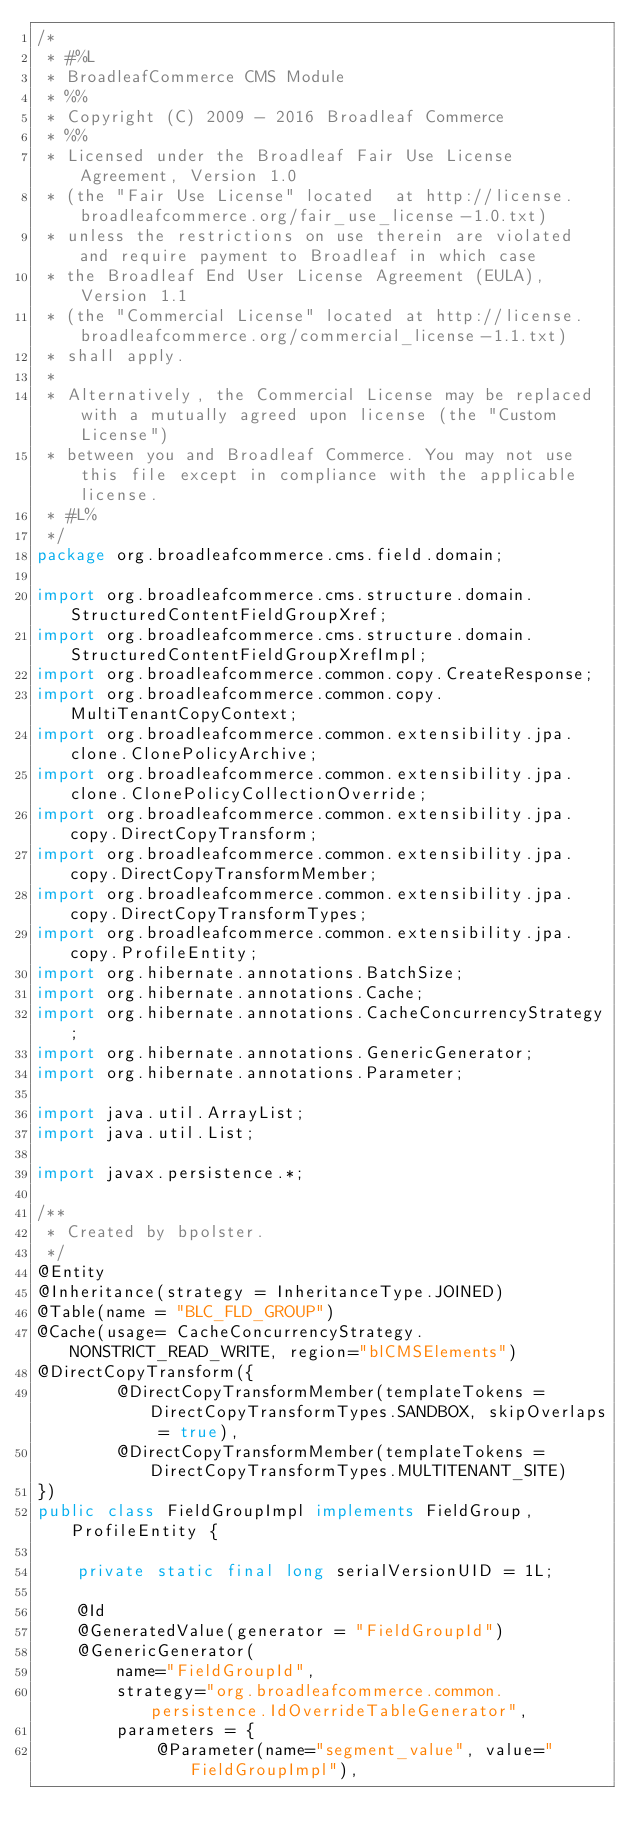<code> <loc_0><loc_0><loc_500><loc_500><_Java_>/*
 * #%L
 * BroadleafCommerce CMS Module
 * %%
 * Copyright (C) 2009 - 2016 Broadleaf Commerce
 * %%
 * Licensed under the Broadleaf Fair Use License Agreement, Version 1.0
 * (the "Fair Use License" located  at http://license.broadleafcommerce.org/fair_use_license-1.0.txt)
 * unless the restrictions on use therein are violated and require payment to Broadleaf in which case
 * the Broadleaf End User License Agreement (EULA), Version 1.1
 * (the "Commercial License" located at http://license.broadleafcommerce.org/commercial_license-1.1.txt)
 * shall apply.
 * 
 * Alternatively, the Commercial License may be replaced with a mutually agreed upon license (the "Custom License")
 * between you and Broadleaf Commerce. You may not use this file except in compliance with the applicable license.
 * #L%
 */
package org.broadleafcommerce.cms.field.domain;

import org.broadleafcommerce.cms.structure.domain.StructuredContentFieldGroupXref;
import org.broadleafcommerce.cms.structure.domain.StructuredContentFieldGroupXrefImpl;
import org.broadleafcommerce.common.copy.CreateResponse;
import org.broadleafcommerce.common.copy.MultiTenantCopyContext;
import org.broadleafcommerce.common.extensibility.jpa.clone.ClonePolicyArchive;
import org.broadleafcommerce.common.extensibility.jpa.clone.ClonePolicyCollectionOverride;
import org.broadleafcommerce.common.extensibility.jpa.copy.DirectCopyTransform;
import org.broadleafcommerce.common.extensibility.jpa.copy.DirectCopyTransformMember;
import org.broadleafcommerce.common.extensibility.jpa.copy.DirectCopyTransformTypes;
import org.broadleafcommerce.common.extensibility.jpa.copy.ProfileEntity;
import org.hibernate.annotations.BatchSize;
import org.hibernate.annotations.Cache;
import org.hibernate.annotations.CacheConcurrencyStrategy;
import org.hibernate.annotations.GenericGenerator;
import org.hibernate.annotations.Parameter;

import java.util.ArrayList;
import java.util.List;

import javax.persistence.*;

/**
 * Created by bpolster.
 */
@Entity
@Inheritance(strategy = InheritanceType.JOINED)
@Table(name = "BLC_FLD_GROUP")
@Cache(usage= CacheConcurrencyStrategy.NONSTRICT_READ_WRITE, region="blCMSElements")
@DirectCopyTransform({
        @DirectCopyTransformMember(templateTokens = DirectCopyTransformTypes.SANDBOX, skipOverlaps = true),
        @DirectCopyTransformMember(templateTokens = DirectCopyTransformTypes.MULTITENANT_SITE)
})
public class FieldGroupImpl implements FieldGroup, ProfileEntity {

    private static final long serialVersionUID = 1L;

    @Id
    @GeneratedValue(generator = "FieldGroupId")
    @GenericGenerator(
        name="FieldGroupId",
        strategy="org.broadleafcommerce.common.persistence.IdOverrideTableGenerator",
        parameters = {
            @Parameter(name="segment_value", value="FieldGroupImpl"),</code> 